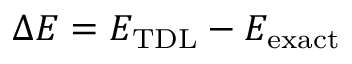<formula> <loc_0><loc_0><loc_500><loc_500>\Delta E = E _ { T D L } - E _ { e x a c t }</formula> 